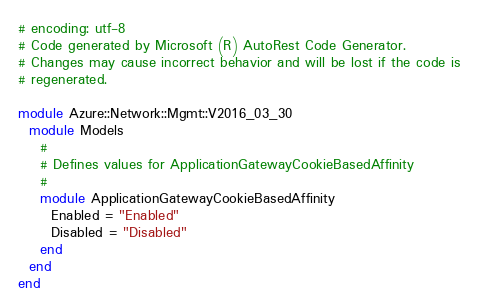Convert code to text. <code><loc_0><loc_0><loc_500><loc_500><_Ruby_># encoding: utf-8
# Code generated by Microsoft (R) AutoRest Code Generator.
# Changes may cause incorrect behavior and will be lost if the code is
# regenerated.

module Azure::Network::Mgmt::V2016_03_30
  module Models
    #
    # Defines values for ApplicationGatewayCookieBasedAffinity
    #
    module ApplicationGatewayCookieBasedAffinity
      Enabled = "Enabled"
      Disabled = "Disabled"
    end
  end
end
</code> 